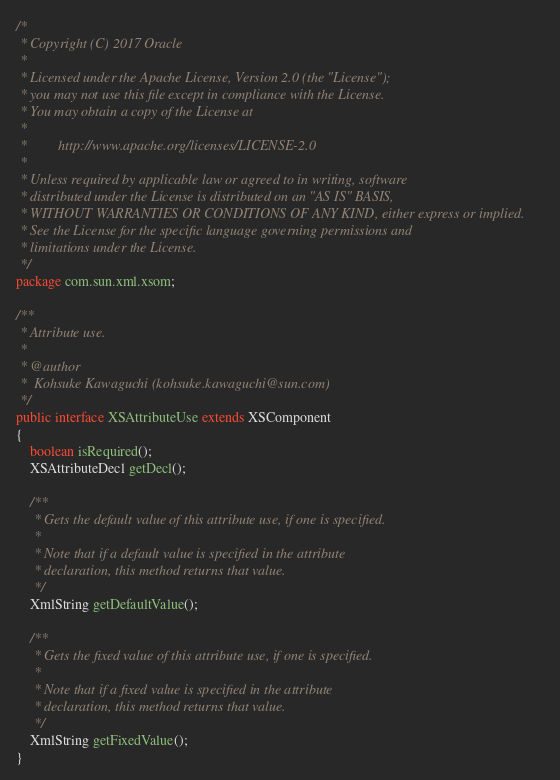<code> <loc_0><loc_0><loc_500><loc_500><_Java_>/*
 * Copyright (C) 2017 Oracle
 *
 * Licensed under the Apache License, Version 2.0 (the "License");
 * you may not use this file except in compliance with the License.
 * You may obtain a copy of the License at
 *
 *         http://www.apache.org/licenses/LICENSE-2.0
 *
 * Unless required by applicable law or agreed to in writing, software
 * distributed under the License is distributed on an "AS IS" BASIS,
 * WITHOUT WARRANTIES OR CONDITIONS OF ANY KIND, either express or implied.
 * See the License for the specific language governing permissions and
 * limitations under the License.
 */
package com.sun.xml.xsom;

/**
 * Attribute use.
 * 
 * @author
 *  Kohsuke Kawaguchi (kohsuke.kawaguchi@sun.com)
 */
public interface XSAttributeUse extends XSComponent
{
    boolean isRequired();
    XSAttributeDecl getDecl();

    /**
     * Gets the default value of this attribute use, if one is specified.
     * 
     * Note that if a default value is specified in the attribute
     * declaration, this method returns that value.
     */
    XmlString getDefaultValue();

    /**
     * Gets the fixed value of this attribute use, if one is specified.
     * 
     * Note that if a fixed value is specified in the attribute
     * declaration, this method returns that value.
     */
    XmlString getFixedValue();
}
</code> 